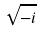Convert formula to latex. <formula><loc_0><loc_0><loc_500><loc_500>\sqrt { - i }</formula> 